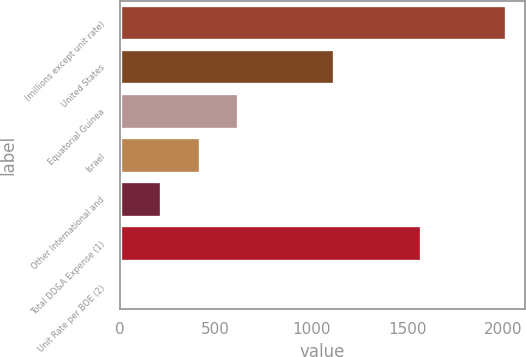Convert chart. <chart><loc_0><loc_0><loc_500><loc_500><bar_chart><fcel>(millions except unit rate)<fcel>United States<fcel>Equatorial Guinea<fcel>Israel<fcel>Other International and<fcel>Total DD&A Expense (1)<fcel>Unit Rate per BOE (2)<nl><fcel>2013<fcel>1117<fcel>615.22<fcel>415.54<fcel>215.86<fcel>1568<fcel>16.18<nl></chart> 